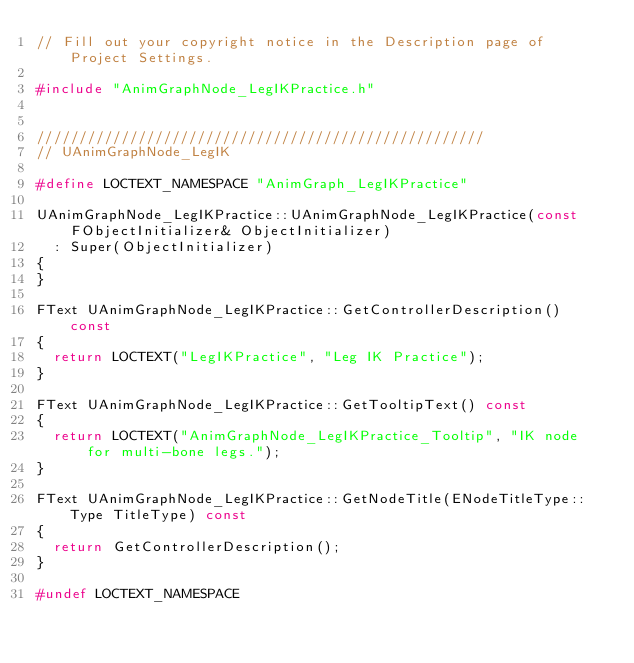Convert code to text. <code><loc_0><loc_0><loc_500><loc_500><_C++_>// Fill out your copyright notice in the Description page of Project Settings.

#include "AnimGraphNode_LegIKPractice.h"


/////////////////////////////////////////////////////
// UAnimGraphNode_LegIK

#define LOCTEXT_NAMESPACE "AnimGraph_LegIKPractice"

UAnimGraphNode_LegIKPractice::UAnimGraphNode_LegIKPractice(const FObjectInitializer& ObjectInitializer)
	: Super(ObjectInitializer)
{
}

FText UAnimGraphNode_LegIKPractice::GetControllerDescription() const
{
	return LOCTEXT("LegIKPractice", "Leg IK Practice");
}

FText UAnimGraphNode_LegIKPractice::GetTooltipText() const
{
	return LOCTEXT("AnimGraphNode_LegIKPractice_Tooltip", "IK node for multi-bone legs.");
}

FText UAnimGraphNode_LegIKPractice::GetNodeTitle(ENodeTitleType::Type TitleType) const
{
	return GetControllerDescription();
}

#undef LOCTEXT_NAMESPACE
</code> 